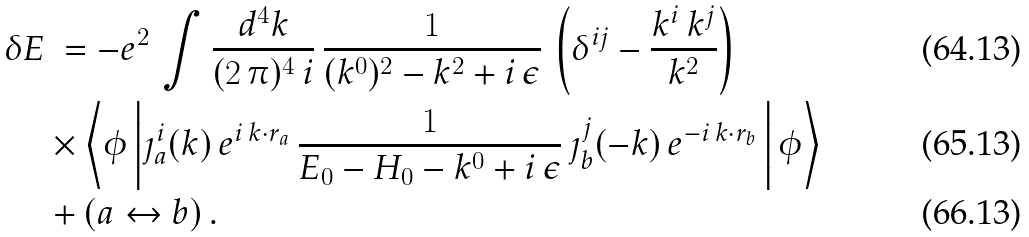Convert formula to latex. <formula><loc_0><loc_0><loc_500><loc_500>\delta E & \ = - e ^ { 2 } \, \int \frac { d ^ { 4 } k } { ( 2 \, \pi ) ^ { 4 } \, i } \, \frac { 1 } { ( k ^ { 0 } ) ^ { 2 } - k ^ { 2 } + i \, \epsilon } \, \left ( \delta ^ { i j } - \frac { k ^ { i } \, k ^ { j } } { k ^ { 2 } } \right ) \, \\ & \times \left \langle \phi \left | \jmath ^ { i } _ { a } ( k ) \, e ^ { i \, k \cdot r _ { a } } \, \frac { 1 } { E _ { 0 } - H _ { 0 } - k ^ { 0 } + i \, \epsilon } \, \jmath ^ { j } _ { b } ( - k ) \, e ^ { - i \, k \cdot r _ { b } } \, \right | \phi \right \rangle \\ & + ( a \leftrightarrow b ) \, .</formula> 